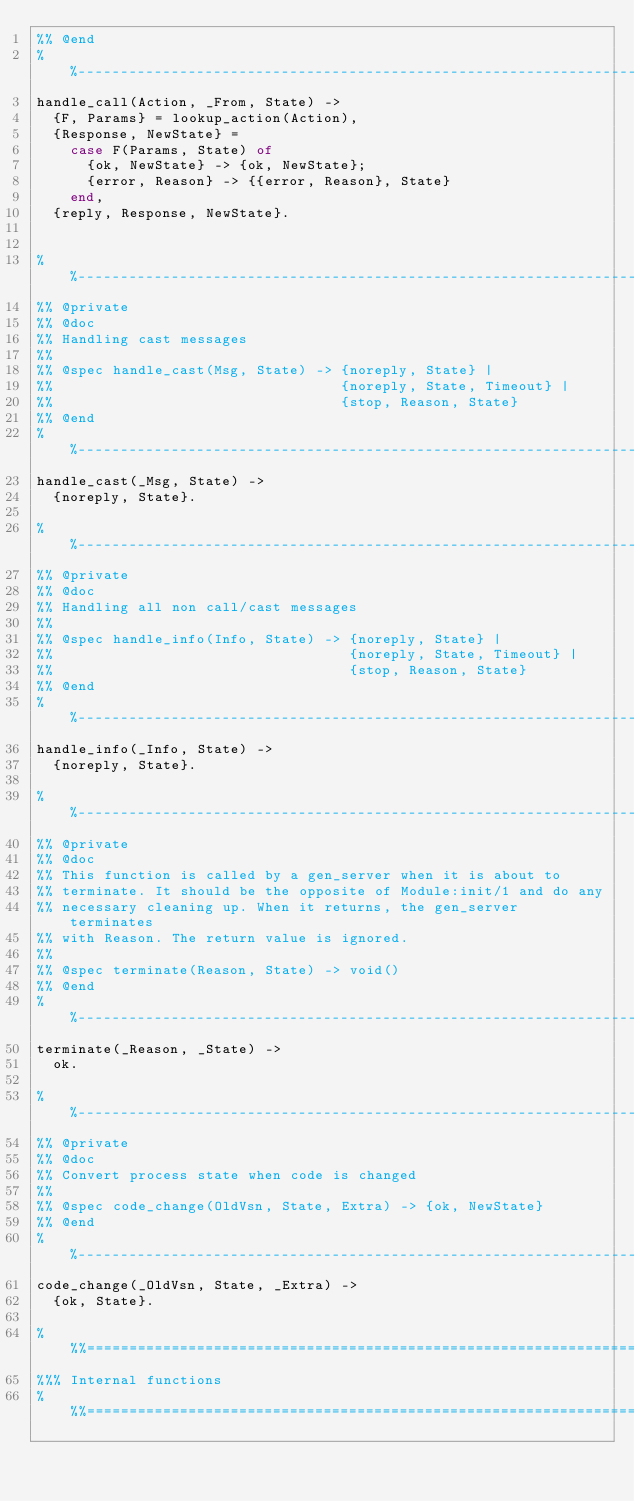Convert code to text. <code><loc_0><loc_0><loc_500><loc_500><_Erlang_>%% @end
%%--------------------------------------------------------------------
handle_call(Action, _From, State) ->
  {F, Params} = lookup_action(Action),
  {Response, NewState} = 
    case F(Params, State) of
      {ok, NewState} -> {ok, NewState};
      {error, Reason} -> {{error, Reason}, State}
    end,
  {reply, Response, NewState}.
        

%%--------------------------------------------------------------------
%% @private
%% @doc
%% Handling cast messages
%%
%% @spec handle_cast(Msg, State) -> {noreply, State} |
%%                                  {noreply, State, Timeout} |
%%                                  {stop, Reason, State}
%% @end
%%--------------------------------------------------------------------
handle_cast(_Msg, State) ->
  {noreply, State}.

%%--------------------------------------------------------------------
%% @private
%% @doc
%% Handling all non call/cast messages
%%
%% @spec handle_info(Info, State) -> {noreply, State} |
%%                                   {noreply, State, Timeout} |
%%                                   {stop, Reason, State}
%% @end
%%--------------------------------------------------------------------
handle_info(_Info, State) ->
  {noreply, State}.

%%--------------------------------------------------------------------
%% @private
%% @doc
%% This function is called by a gen_server when it is about to
%% terminate. It should be the opposite of Module:init/1 and do any
%% necessary cleaning up. When it returns, the gen_server terminates
%% with Reason. The return value is ignored.
%%
%% @spec terminate(Reason, State) -> void()
%% @end
%%--------------------------------------------------------------------
terminate(_Reason, _State) ->
  ok.

%%--------------------------------------------------------------------
%% @private
%% @doc
%% Convert process state when code is changed
%%
%% @spec code_change(OldVsn, State, Extra) -> {ok, NewState}
%% @end
%%--------------------------------------------------------------------
code_change(_OldVsn, State, _Extra) ->
  {ok, State}.

%%%===================================================================
%%% Internal functions
%%%===================================================================
</code> 